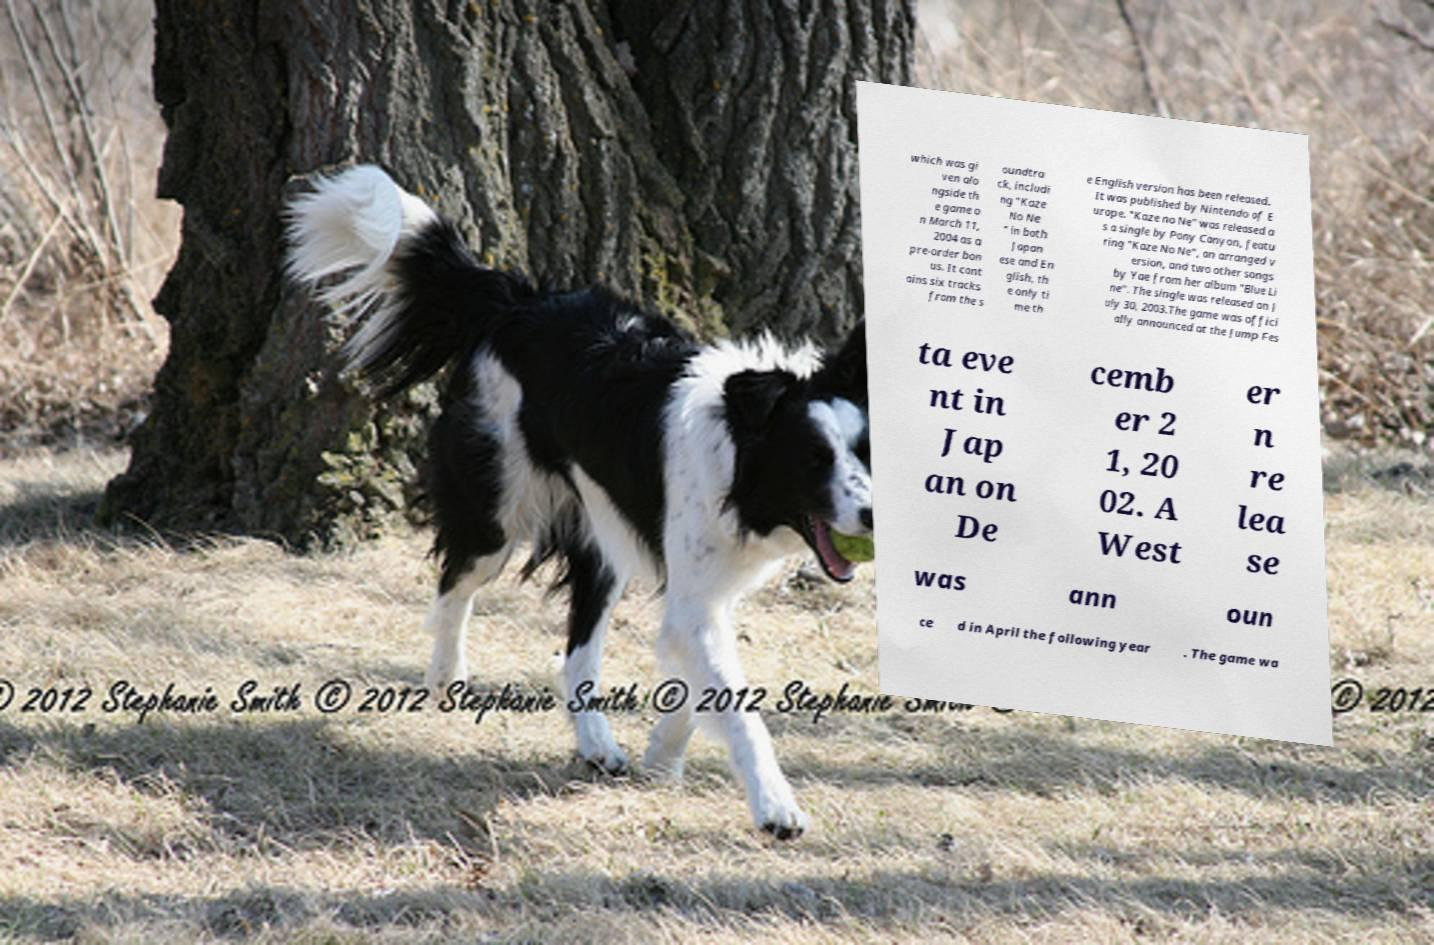Can you read and provide the text displayed in the image?This photo seems to have some interesting text. Can you extract and type it out for me? which was gi ven alo ngside th e game o n March 11, 2004 as a pre-order bon us. It cont ains six tracks from the s oundtra ck, includi ng "Kaze No Ne " in both Japan ese and En glish, th e only ti me th e English version has been released. It was published by Nintendo of E urope. "Kaze no Ne" was released a s a single by Pony Canyon, featu ring "Kaze No Ne", an arranged v ersion, and two other songs by Yae from her album "Blue Li ne". The single was released on J uly 30, 2003.The game was offici ally announced at the Jump Fes ta eve nt in Jap an on De cemb er 2 1, 20 02. A West er n re lea se was ann oun ce d in April the following year . The game wa 